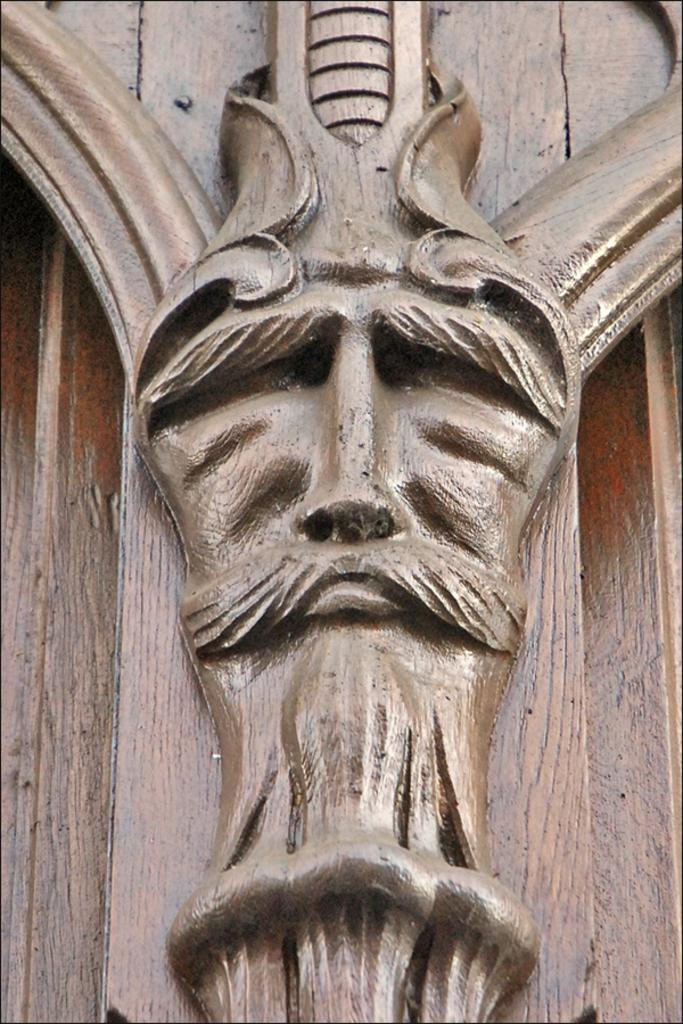What is the main subject of the image? There is a sculpture in the image. What type of patch can be seen on the back of the sculpture in the image? There is no patch or reference to a back in the image, as it features a sculpture without any additional details. 